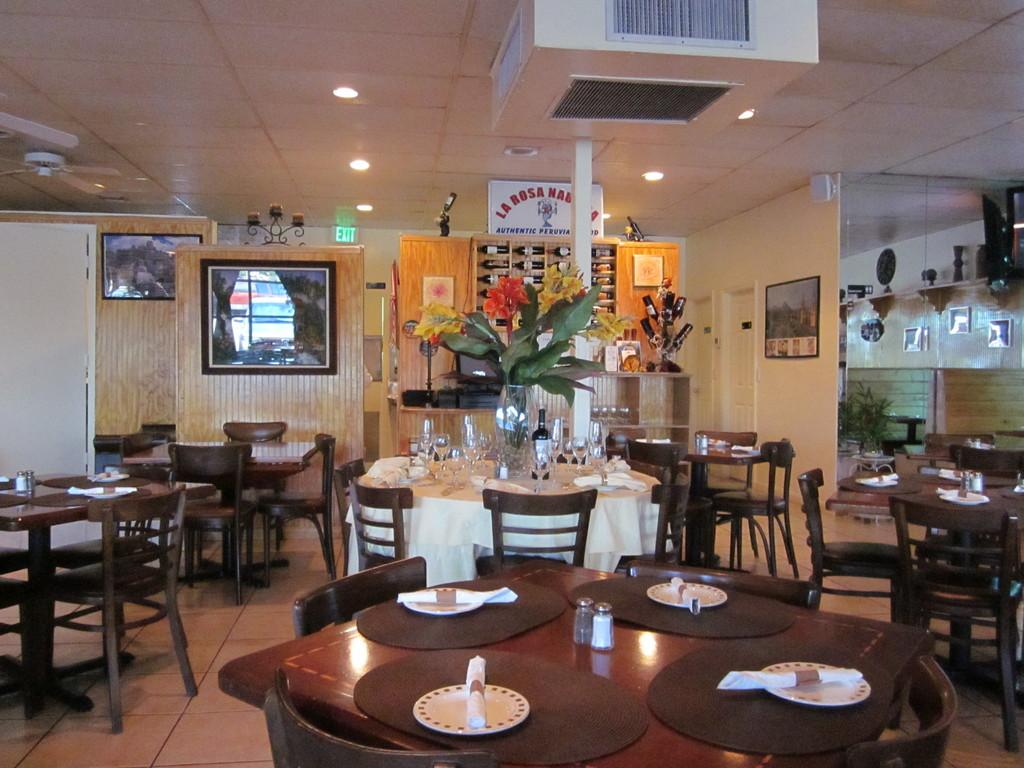What type of room is depicted in the image? The room appears to be a dining room. What furniture is present in the dining room? There are dining tables and chairs in the room. What feature can be seen on the ceiling of the room? There are lights on the roof of the room. What type of crack can be seen on the table in the image? There is no crack visible on the table in the image. What color is the hair on the chair in the image? There is no hair present on the chairs in the image. 